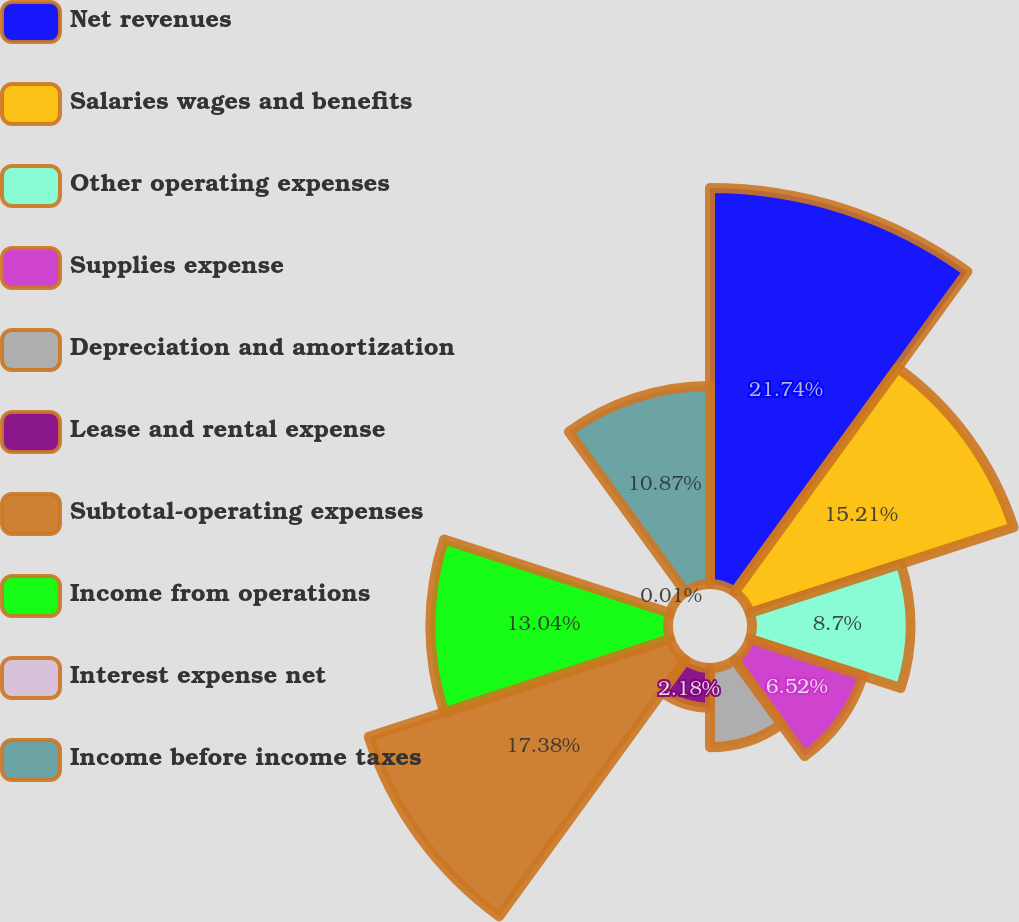Convert chart. <chart><loc_0><loc_0><loc_500><loc_500><pie_chart><fcel>Net revenues<fcel>Salaries wages and benefits<fcel>Other operating expenses<fcel>Supplies expense<fcel>Depreciation and amortization<fcel>Lease and rental expense<fcel>Subtotal-operating expenses<fcel>Income from operations<fcel>Interest expense net<fcel>Income before income taxes<nl><fcel>21.73%<fcel>15.21%<fcel>8.7%<fcel>6.52%<fcel>4.35%<fcel>2.18%<fcel>17.38%<fcel>13.04%<fcel>0.01%<fcel>10.87%<nl></chart> 